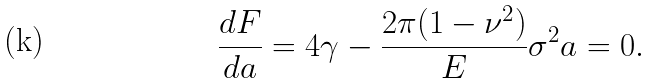Convert formula to latex. <formula><loc_0><loc_0><loc_500><loc_500>\frac { d F } { d a } = 4 \gamma - \frac { 2 \pi ( 1 - \nu ^ { 2 } ) } { E } \sigma ^ { 2 } a = 0 .</formula> 